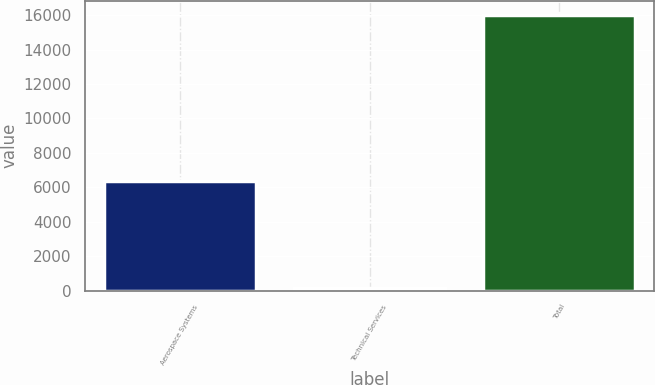Convert chart. <chart><loc_0><loc_0><loc_500><loc_500><bar_chart><fcel>Aerospace Systems<fcel>Technical Services<fcel>Total<nl><fcel>6335<fcel>145<fcel>16019<nl></chart> 